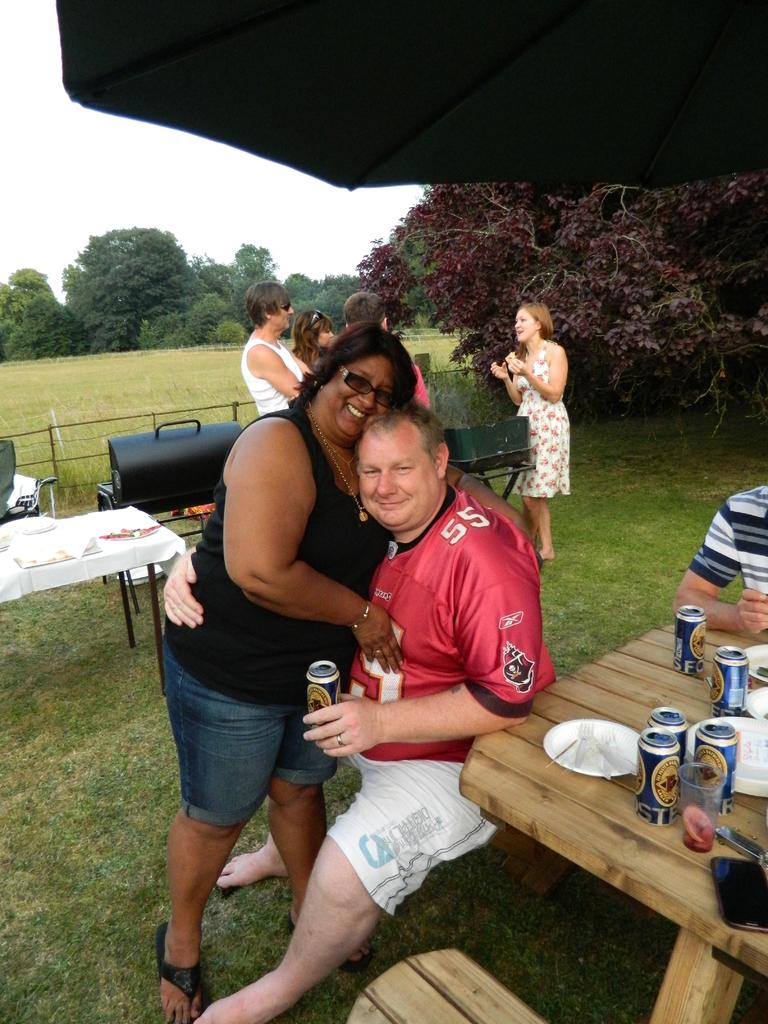<image>
Summarize the visual content of the image. A man in a red number 55 jersey and an woman in a black tank top pose together at a picnic. 